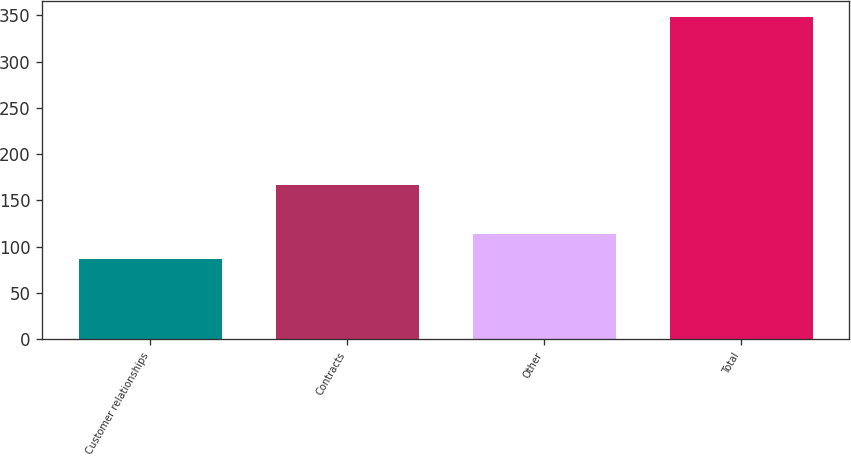Convert chart to OTSL. <chart><loc_0><loc_0><loc_500><loc_500><bar_chart><fcel>Customer relationships<fcel>Contracts<fcel>Other<fcel>Total<nl><fcel>87<fcel>167<fcel>113.1<fcel>348<nl></chart> 